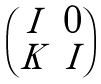Convert formula to latex. <formula><loc_0><loc_0><loc_500><loc_500>\begin{pmatrix} I & 0 \\ K & I \end{pmatrix}</formula> 